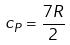<formula> <loc_0><loc_0><loc_500><loc_500>c _ { P } = \frac { 7 R } { 2 }</formula> 